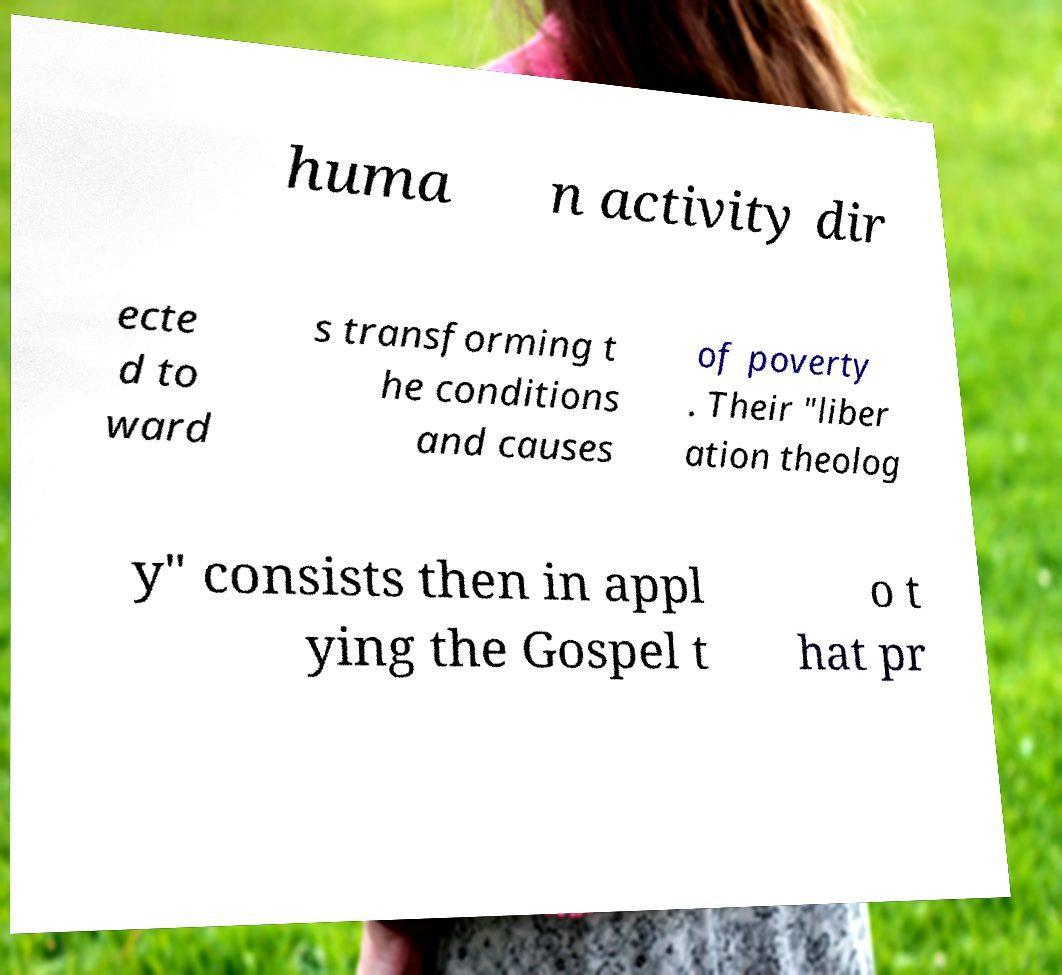Can you read and provide the text displayed in the image?This photo seems to have some interesting text. Can you extract and type it out for me? huma n activity dir ecte d to ward s transforming t he conditions and causes of poverty . Their "liber ation theolog y" consists then in appl ying the Gospel t o t hat pr 